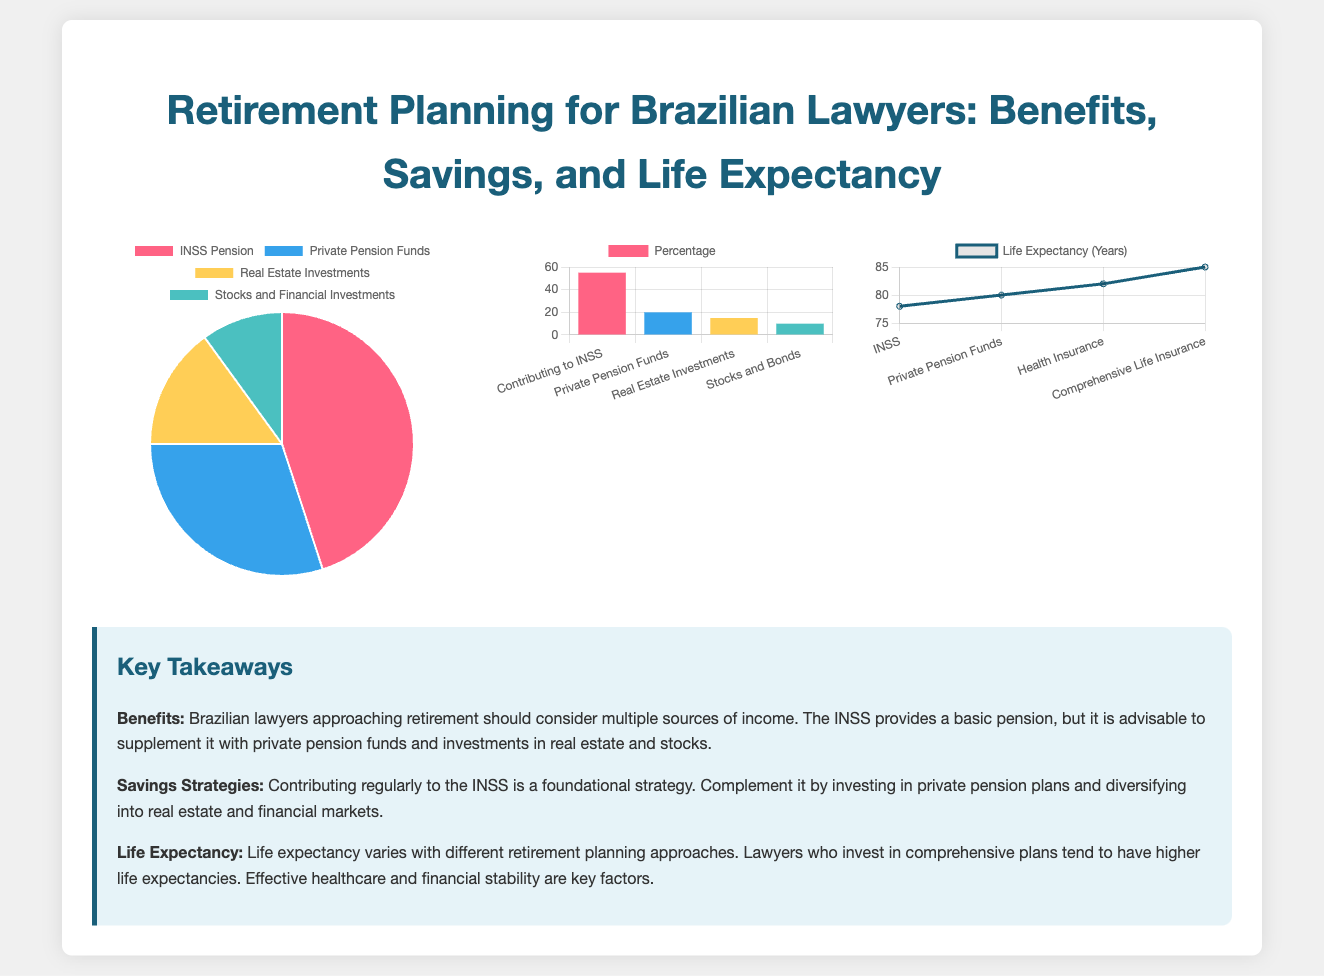What is the largest source of benefits for Brazilian lawyers? The largest source of benefits is the INSS Pension, which accounts for 45% of the total benefits based on the pie chart.
Answer: INSS Pension What percentage of savings comes from contributing to INSS? The bar chart indicates that contributing to INSS constitutes 55% of the savings strategies.
Answer: 55% What is the life expectancy for those with Comprehensive Life Insurance? According to the line chart, the life expectancy for those with Comprehensive Life Insurance is 85 years.
Answer: 85 Which source of benefit has the lowest percentage? The pie chart shows that Stocks and Financial Investments have the lowest percentage of benefits at 10%.
Answer: Stocks and Financial Investments What is the total percentage of benefits from Private Pension Funds and Real Estate Investments combined? The combined percentage from Private Pension Funds (30%) and Real Estate Investments (15%) totals 45%.
Answer: 45% What strategy appears to be the least utilized for savings? The bar chart indicates that the least utilized strategy for savings is Stocks and Bonds at 10%.
Answer: Stocks and Bonds How much higher is the life expectancy for those with Health Insurance compared to INSS? The life expectancy with Health Insurance is 82 years, which is 4 years higher than the 78 years for INSS, based on the line chart.
Answer: 4 years What color represents Real Estate Investments in the benefits pie chart? Real Estate Investments are represented by the color yellow (#FFCE56) in the benefits pie chart.
Answer: Yellow What percentage of savings comes from investing in Real Estate? The bar chart shows that investing in Real Estate accounts for 15% of the savings strategies.
Answer: 15% What does effective healthcare contribute to in retirement plans? Effective healthcare is cited as a key factor contributing to higher life expectancy in comprehensive retirement plans.
Answer: Higher life expectancy 